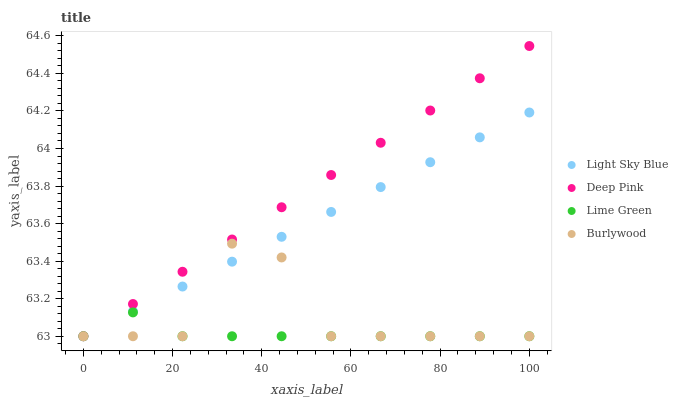Does Lime Green have the minimum area under the curve?
Answer yes or no. Yes. Does Deep Pink have the maximum area under the curve?
Answer yes or no. Yes. Does Light Sky Blue have the minimum area under the curve?
Answer yes or no. No. Does Light Sky Blue have the maximum area under the curve?
Answer yes or no. No. Is Light Sky Blue the smoothest?
Answer yes or no. Yes. Is Burlywood the roughest?
Answer yes or no. Yes. Is Lime Green the smoothest?
Answer yes or no. No. Is Lime Green the roughest?
Answer yes or no. No. Does Burlywood have the lowest value?
Answer yes or no. Yes. Does Deep Pink have the highest value?
Answer yes or no. Yes. Does Light Sky Blue have the highest value?
Answer yes or no. No. Does Light Sky Blue intersect Deep Pink?
Answer yes or no. Yes. Is Light Sky Blue less than Deep Pink?
Answer yes or no. No. Is Light Sky Blue greater than Deep Pink?
Answer yes or no. No. 